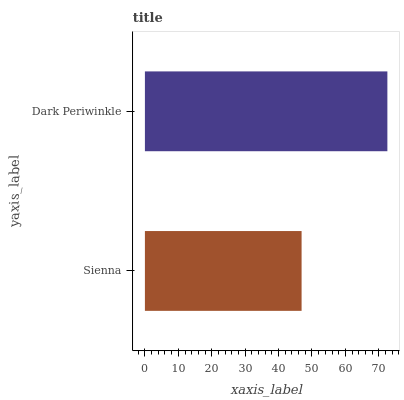Is Sienna the minimum?
Answer yes or no. Yes. Is Dark Periwinkle the maximum?
Answer yes or no. Yes. Is Dark Periwinkle the minimum?
Answer yes or no. No. Is Dark Periwinkle greater than Sienna?
Answer yes or no. Yes. Is Sienna less than Dark Periwinkle?
Answer yes or no. Yes. Is Sienna greater than Dark Periwinkle?
Answer yes or no. No. Is Dark Periwinkle less than Sienna?
Answer yes or no. No. Is Dark Periwinkle the high median?
Answer yes or no. Yes. Is Sienna the low median?
Answer yes or no. Yes. Is Sienna the high median?
Answer yes or no. No. Is Dark Periwinkle the low median?
Answer yes or no. No. 